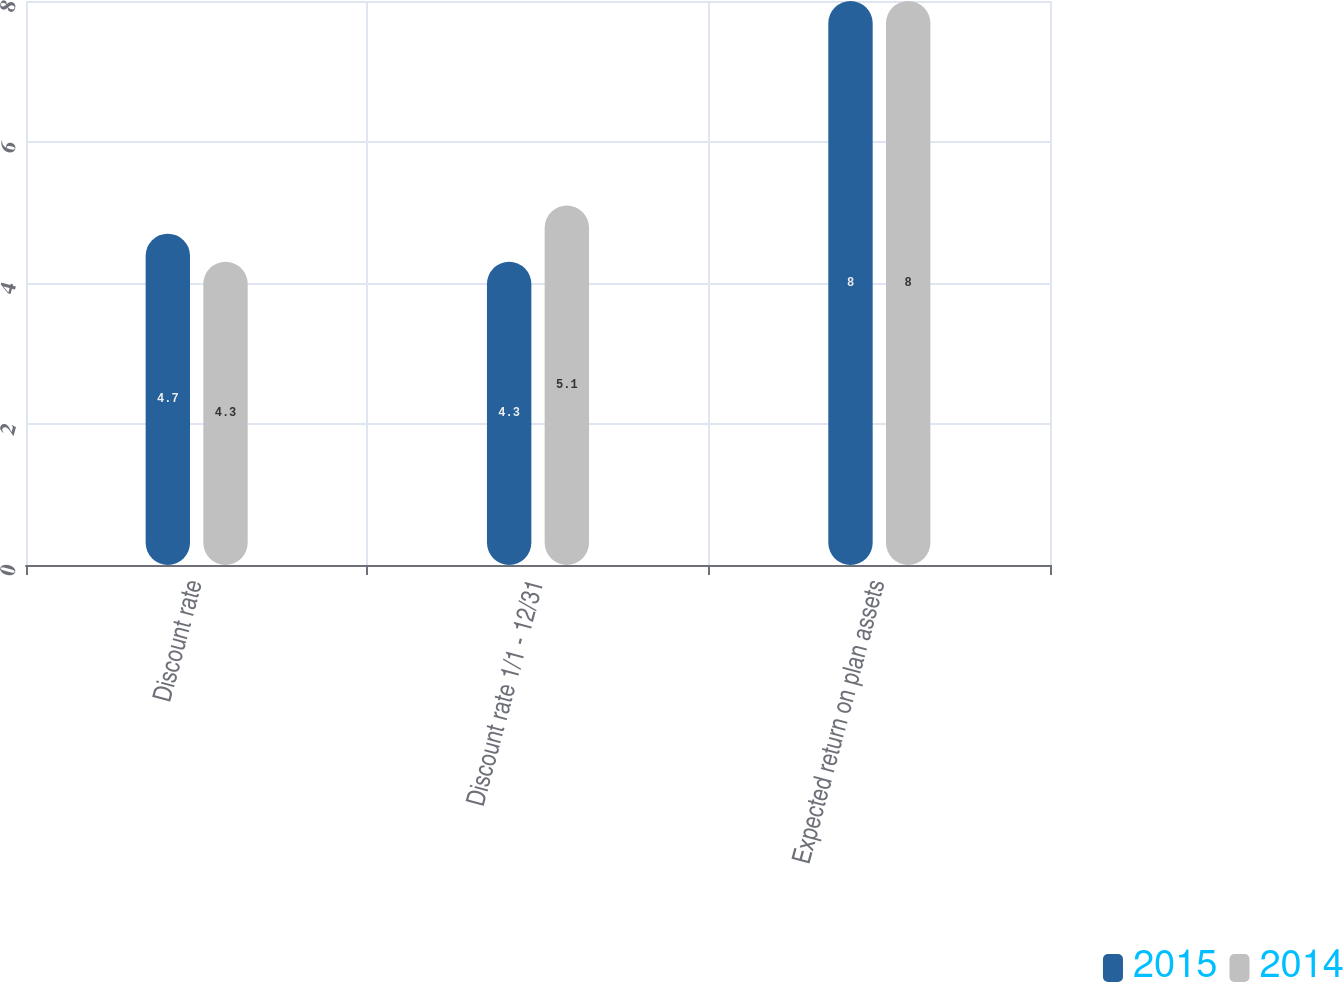Convert chart. <chart><loc_0><loc_0><loc_500><loc_500><stacked_bar_chart><ecel><fcel>Discount rate<fcel>Discount rate 1/1 - 12/31<fcel>Expected return on plan assets<nl><fcel>2015<fcel>4.7<fcel>4.3<fcel>8<nl><fcel>2014<fcel>4.3<fcel>5.1<fcel>8<nl></chart> 